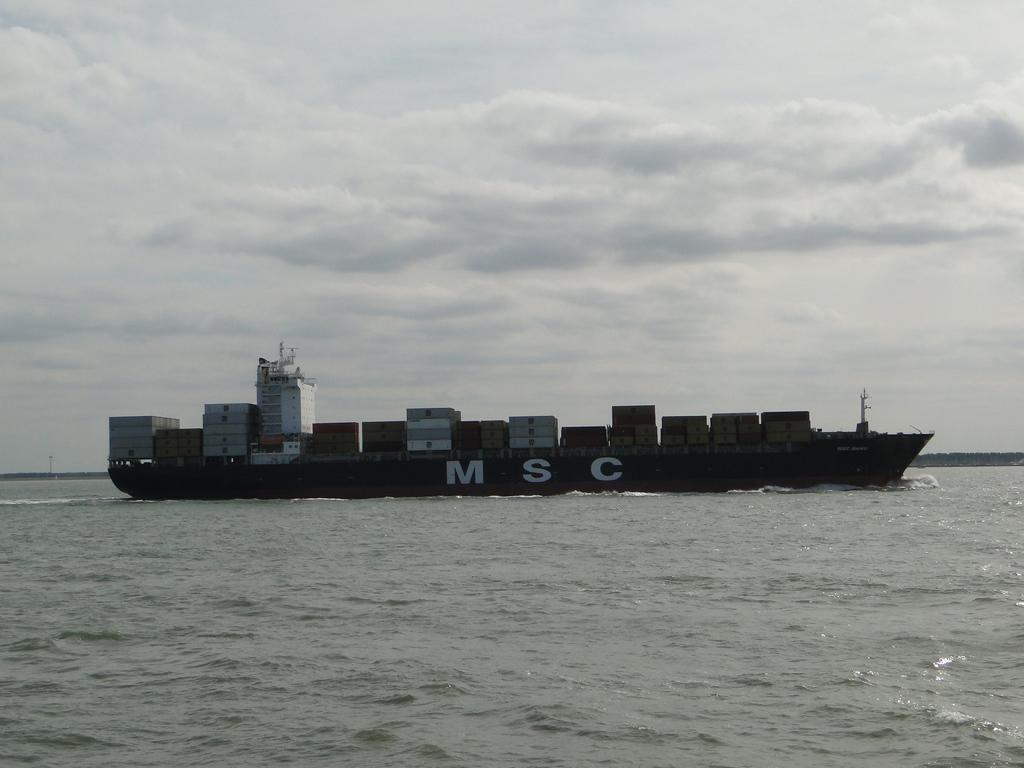What is the main subject of the image? The main subject of the image is a ship. Where is the ship located? The ship is on the sea. What can be seen in the background of the image? The sky is visible in the background of the image. What type of map is being used by the ship in the image? There is no map present in the image; it only shows a ship on the sea with the sky visible in the background. 